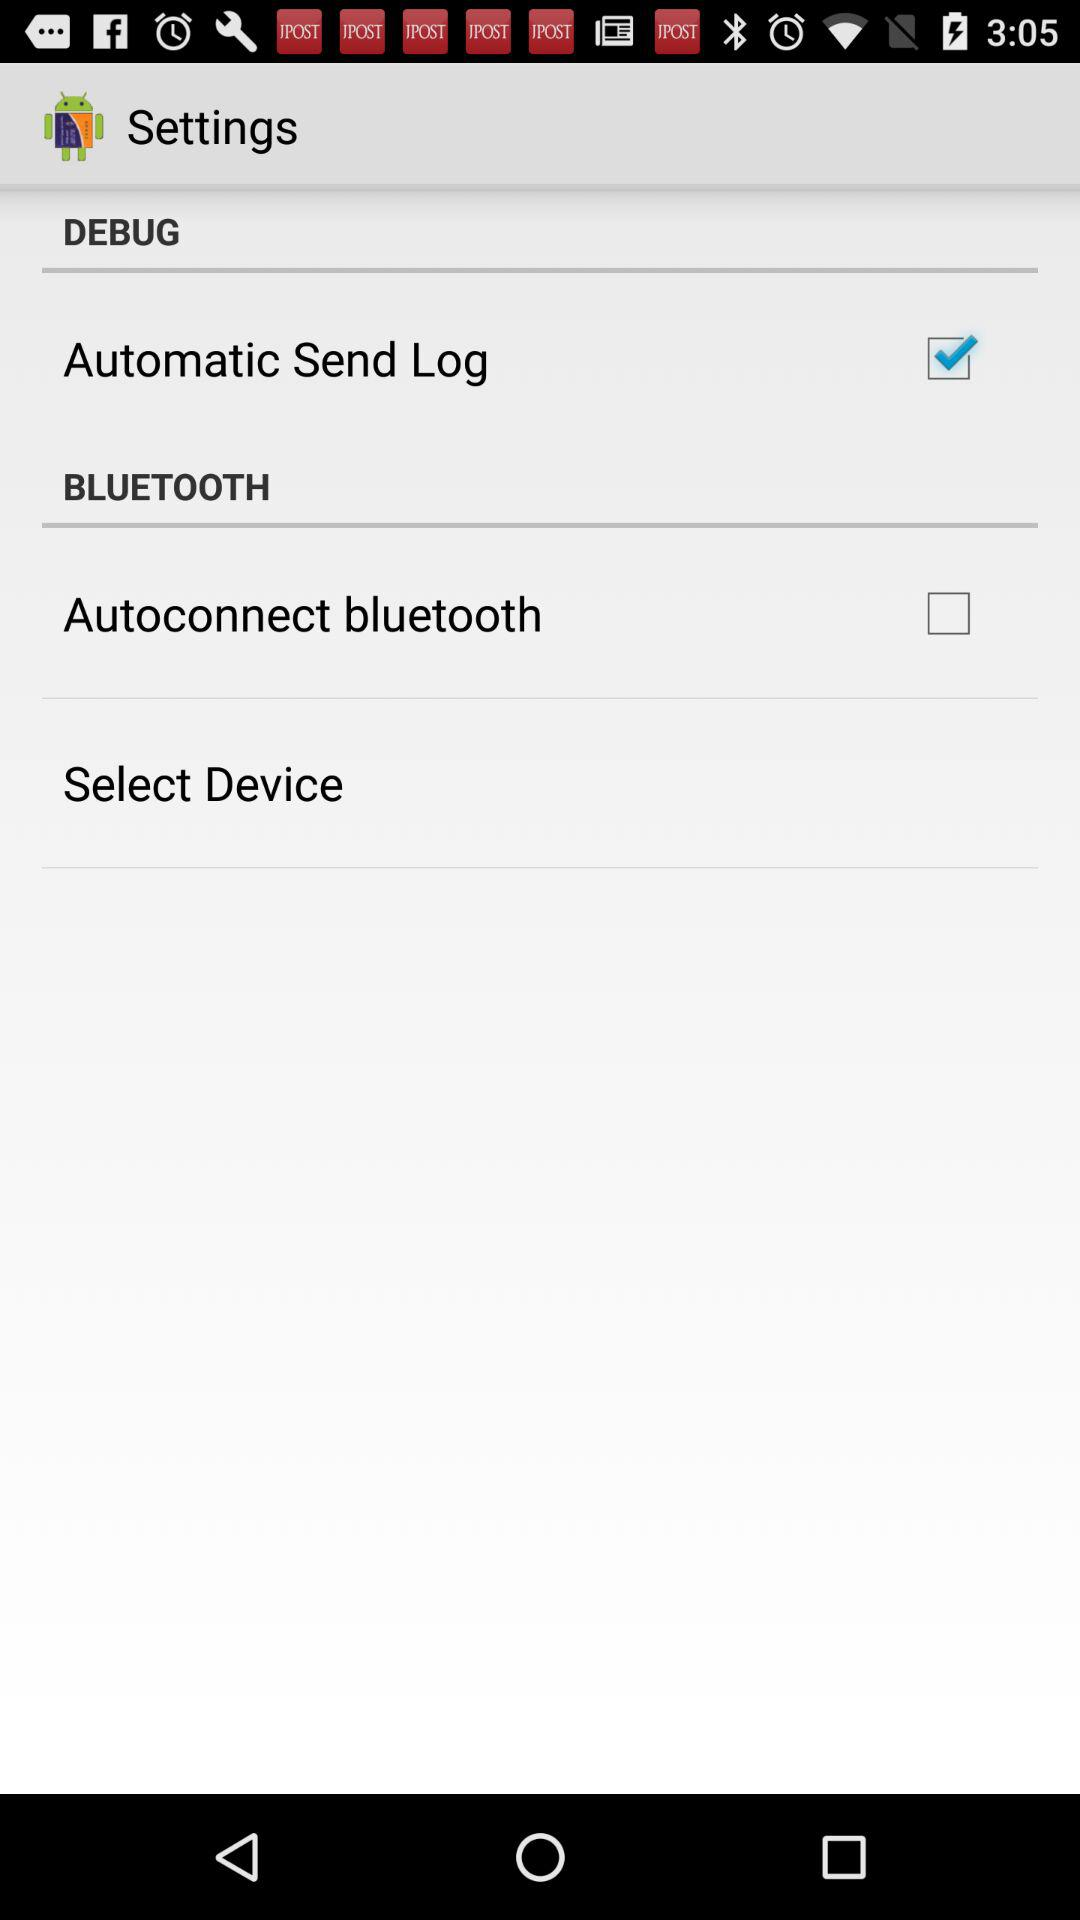Which setting has been checked? The checked setting is "Automatic Send Log". 